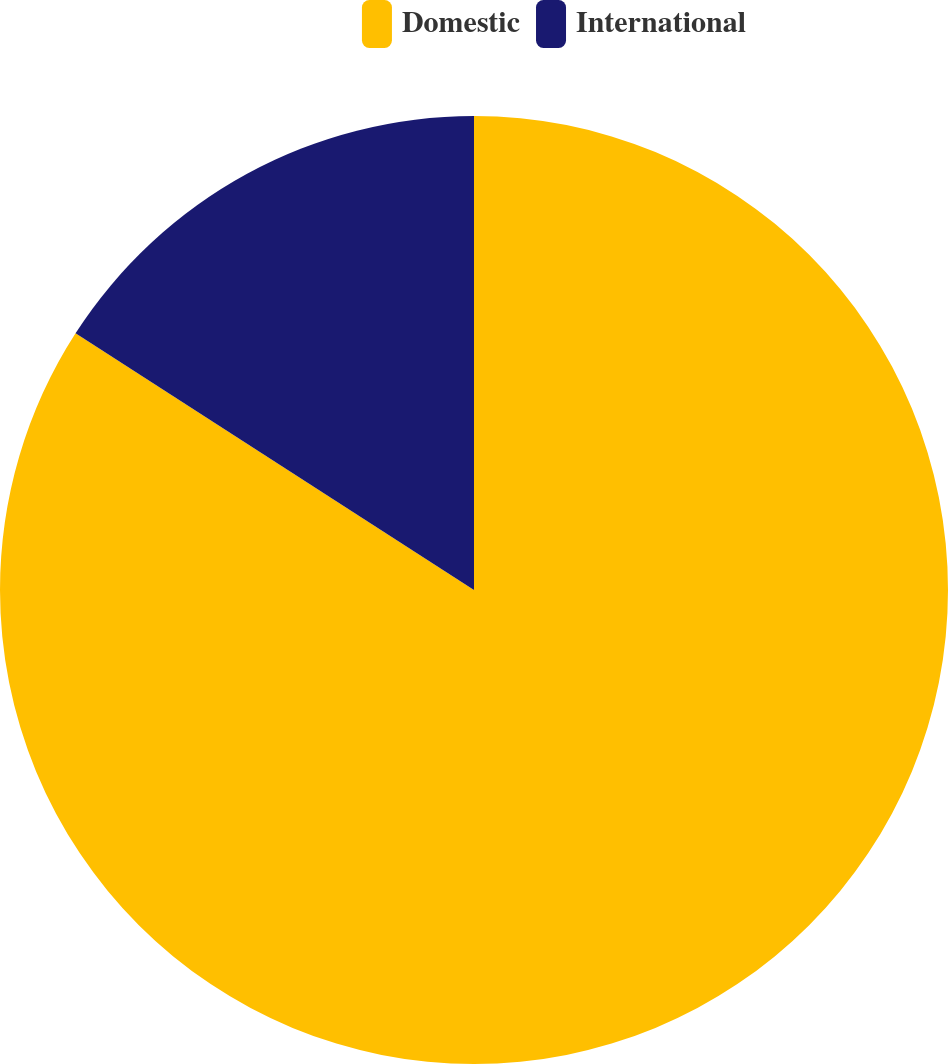<chart> <loc_0><loc_0><loc_500><loc_500><pie_chart><fcel>Domestic<fcel>International<nl><fcel>84.11%<fcel>15.89%<nl></chart> 